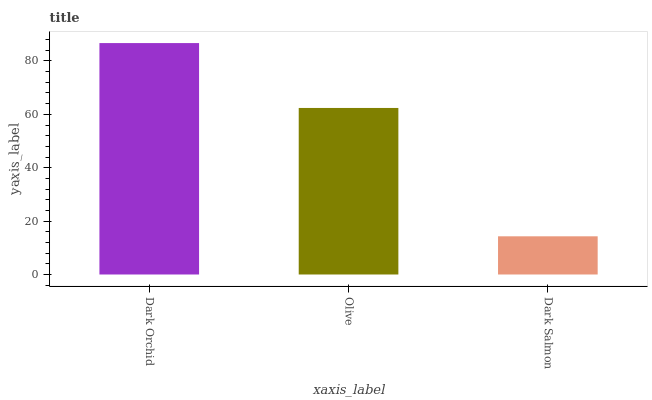Is Dark Salmon the minimum?
Answer yes or no. Yes. Is Dark Orchid the maximum?
Answer yes or no. Yes. Is Olive the minimum?
Answer yes or no. No. Is Olive the maximum?
Answer yes or no. No. Is Dark Orchid greater than Olive?
Answer yes or no. Yes. Is Olive less than Dark Orchid?
Answer yes or no. Yes. Is Olive greater than Dark Orchid?
Answer yes or no. No. Is Dark Orchid less than Olive?
Answer yes or no. No. Is Olive the high median?
Answer yes or no. Yes. Is Olive the low median?
Answer yes or no. Yes. Is Dark Salmon the high median?
Answer yes or no. No. Is Dark Orchid the low median?
Answer yes or no. No. 